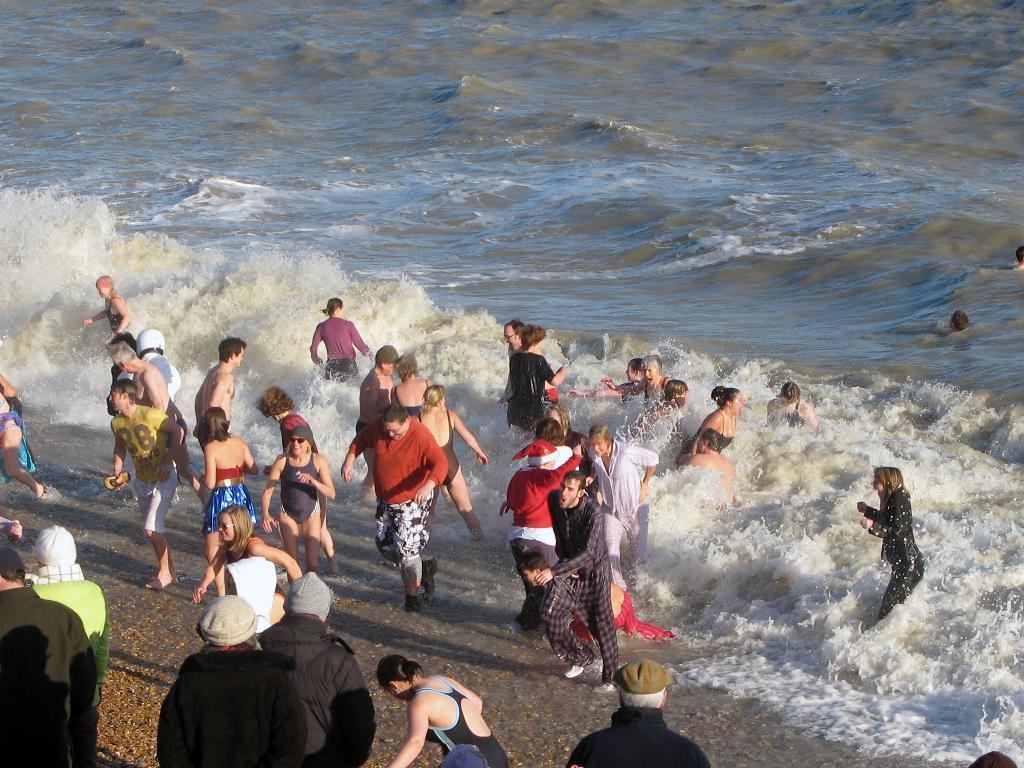How many people are in the image? There are people in the image, but the exact number is not specified. What are some of the people doing in the image? Some of the people are walking in the image. What type of terrain is visible in the image? There is sand and water visible in the image. What type of meat can be seen cooking on a grill in the image? There is no grill or meat present in the image; it features people walking on sand and near water. How many matches are visible in the image? There are no matches present in the image. 